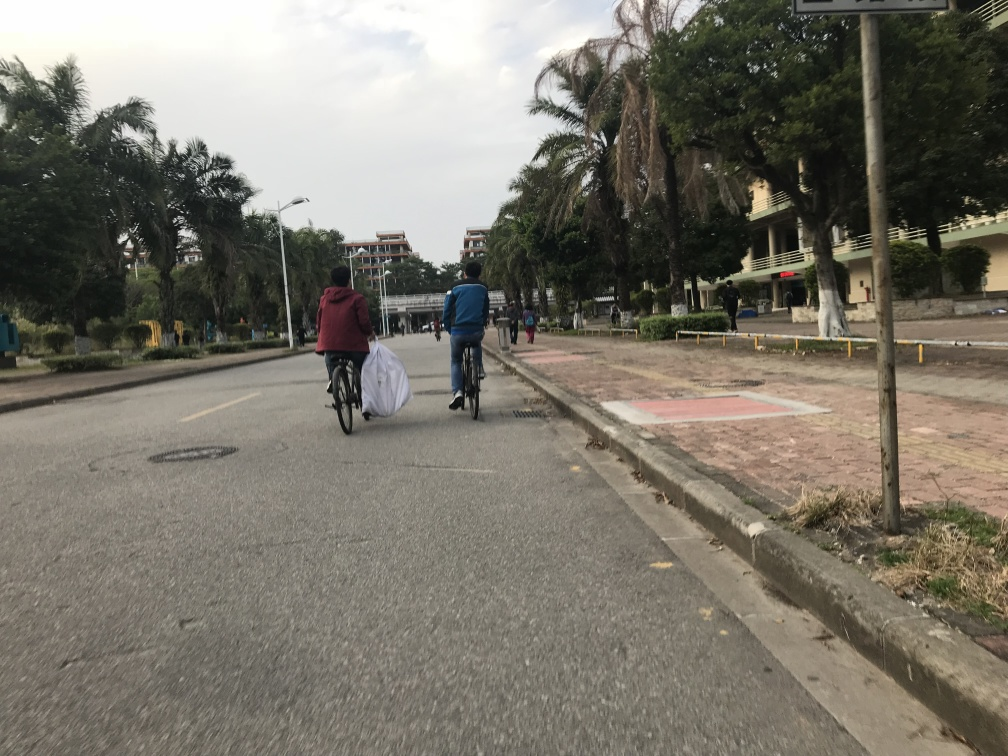What can you tell me about the urban planning or infrastructure visible in the image? The image showcases a well-defined urban infrastructure with a clearly marked bicycle lane adjacent to the pedestrian walkway. Both are separated from the vehicle lane, prioritizing safety for cyclists and pedestrians. The presence of tropical trees and urban greenery suggests an effort to include nature within the urban setting, which can enhance the aesthetic value of the area and provide environmental benefits. The buildings in the background appear to be multi-storey, indicating a residential or perhaps educational facility area given the style of the architecture and the pedestrian traffic.  How would you assess the level of activity in this area based on the image? The level of activity in this area appears to be relatively calm at the time the photo was taken. A few individuals are seen in the distance, but there is no sign of congestion or crowdedness. The cyclists and pedestrians present are spaced out, further indicating a peaceful, non-rushed environment. This could point to a time of day when people are not in a hurry, such as mid-morning or early afternoon, or it could reflect a generally tranquil area with lower footfall and commuter traffic. 